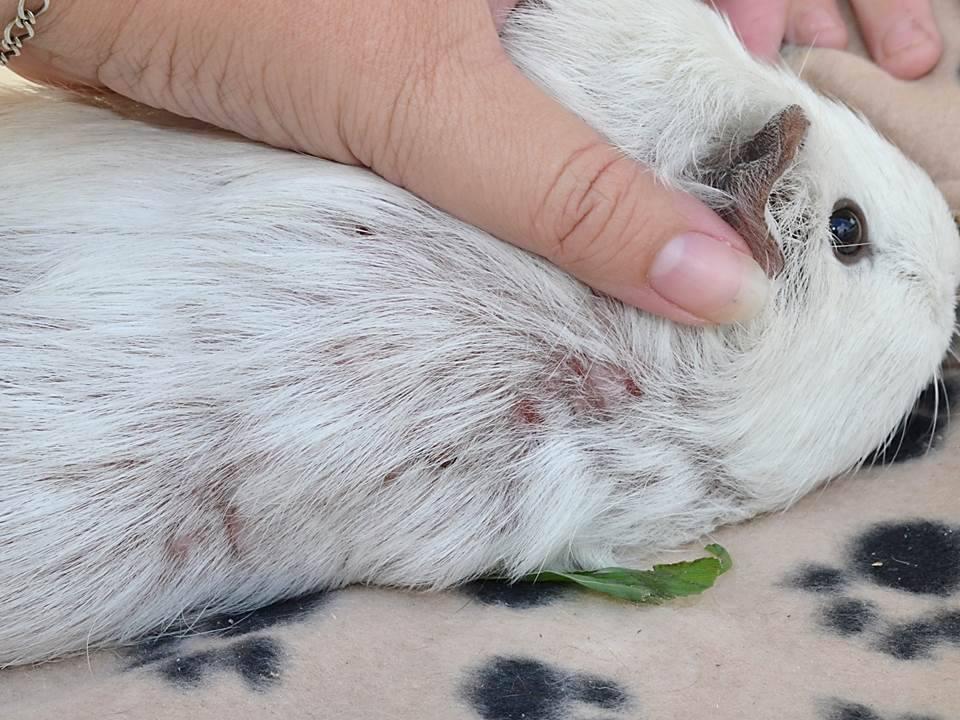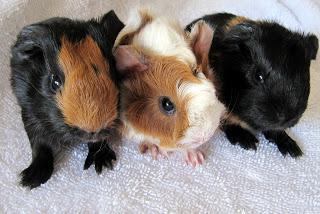The first image is the image on the left, the second image is the image on the right. Examine the images to the left and right. Is the description "No image contains more than two guinea pigs, and one image features two multi-color guinea pigs posed side-by-side and facing straight ahead." accurate? Answer yes or no. No. The first image is the image on the left, the second image is the image on the right. Given the left and right images, does the statement "One images shows only one guinea pig and the other shows at least two." hold true? Answer yes or no. Yes. 